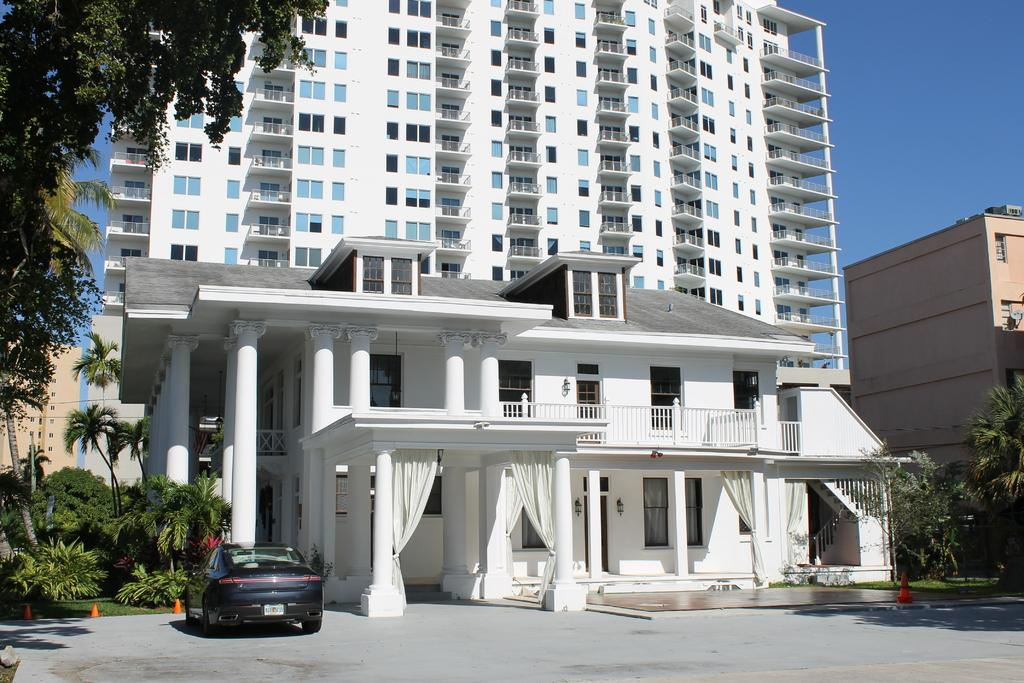What color is the vehicle in the image? The vehicle in the image is black-colored. What type of vegetation is present in the image? There are trees in the image, and they are green. What can be seen in the background of the image? There are buildings in the background of the image, and they are white and cream-colored. What is the color of the sky in the image? The sky is blue in the image. What type of bread is visible in the image? There is no bread present in the image. How many heads can be seen in the image? There are no heads visible in the image. 